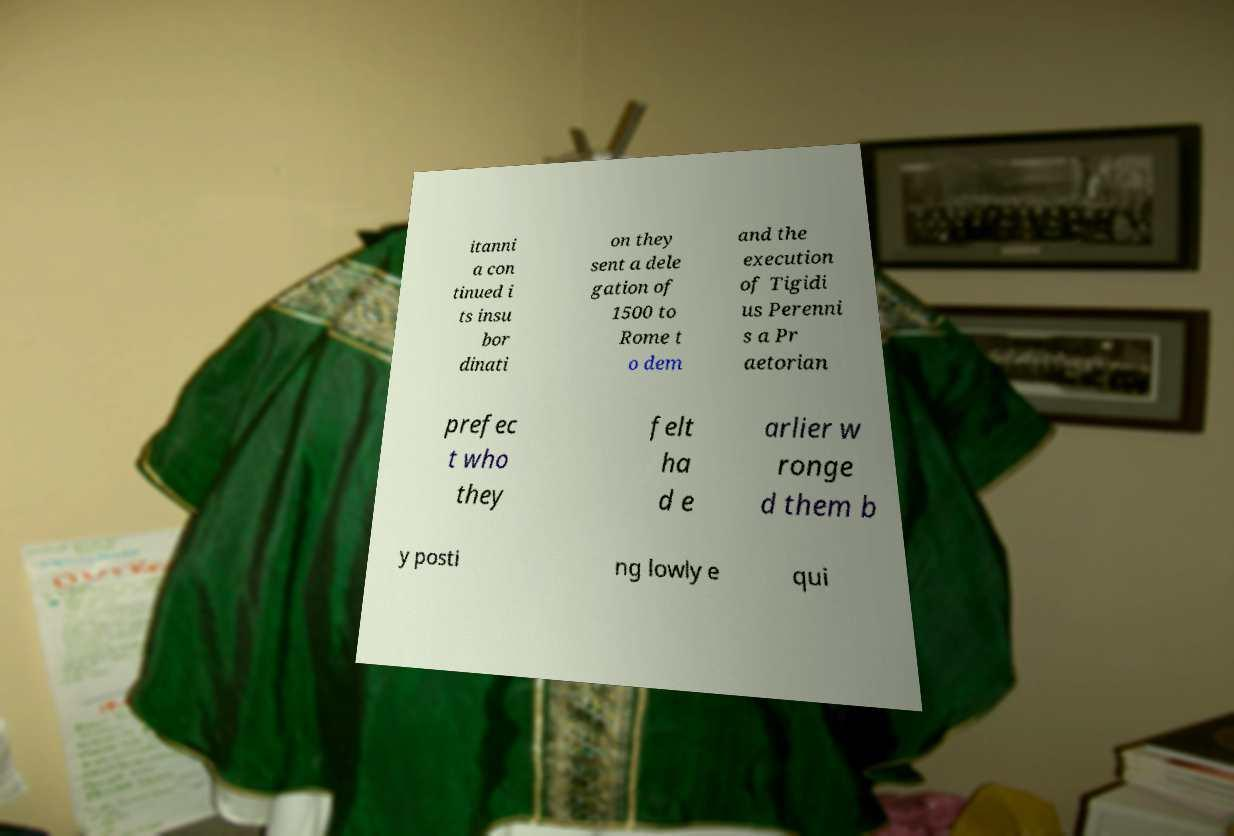Could you extract and type out the text from this image? itanni a con tinued i ts insu bor dinati on they sent a dele gation of 1500 to Rome t o dem and the execution of Tigidi us Perenni s a Pr aetorian prefec t who they felt ha d e arlier w ronge d them b y posti ng lowly e qui 